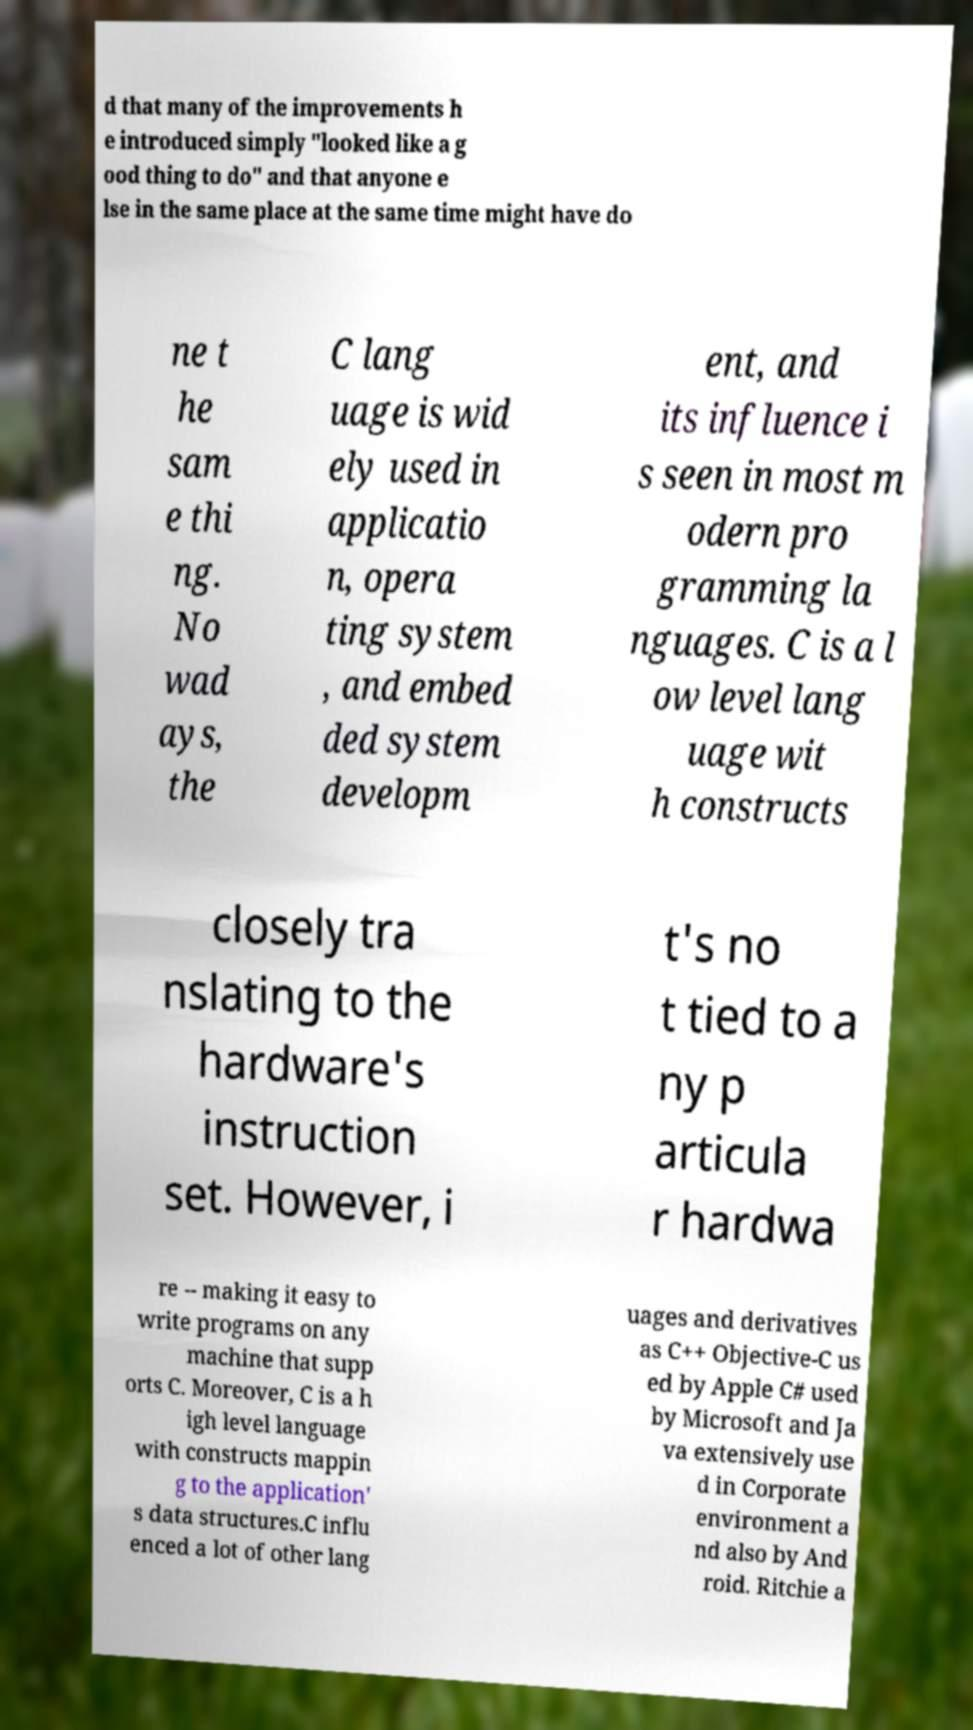Can you read and provide the text displayed in the image?This photo seems to have some interesting text. Can you extract and type it out for me? d that many of the improvements h e introduced simply "looked like a g ood thing to do" and that anyone e lse in the same place at the same time might have do ne t he sam e thi ng. No wad ays, the C lang uage is wid ely used in applicatio n, opera ting system , and embed ded system developm ent, and its influence i s seen in most m odern pro gramming la nguages. C is a l ow level lang uage wit h constructs closely tra nslating to the hardware's instruction set. However, i t's no t tied to a ny p articula r hardwa re -- making it easy to write programs on any machine that supp orts C. Moreover, C is a h igh level language with constructs mappin g to the application' s data structures.C influ enced a lot of other lang uages and derivatives as C++ Objective-C us ed by Apple C# used by Microsoft and Ja va extensively use d in Corporate environment a nd also by And roid. Ritchie a 